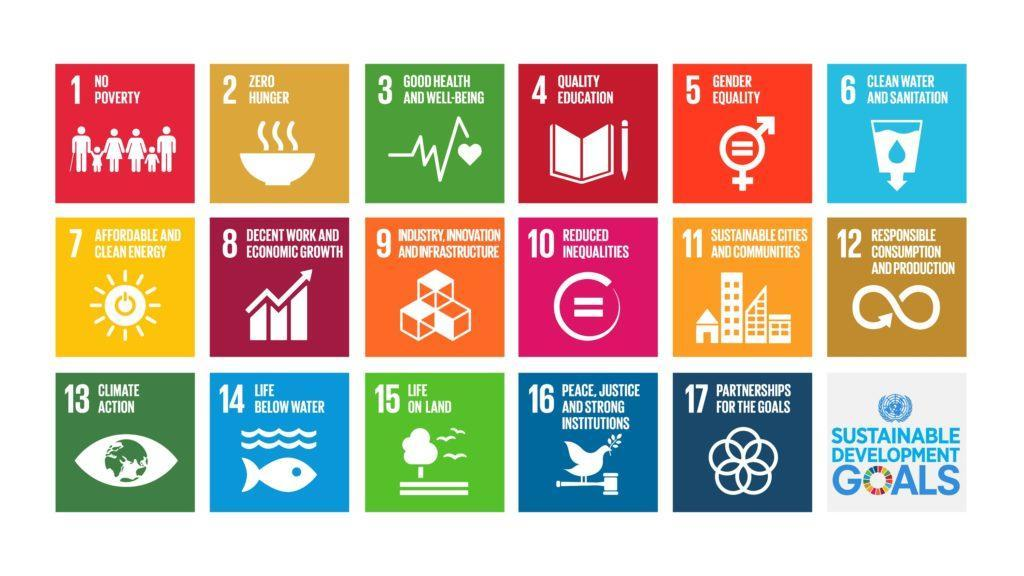which sustainable goal is defined by the cell in the 2nd row and 1st column
Answer the question with a short phrase. affordable and clean energy which sustainable goal is defined by the cell in the 2nd row and 3rd column Industry innovation and infrastructure what goal is denoted by book and pencil quality education how many goals are shown in the last row 5 what goal is defined by fish and water life below water 